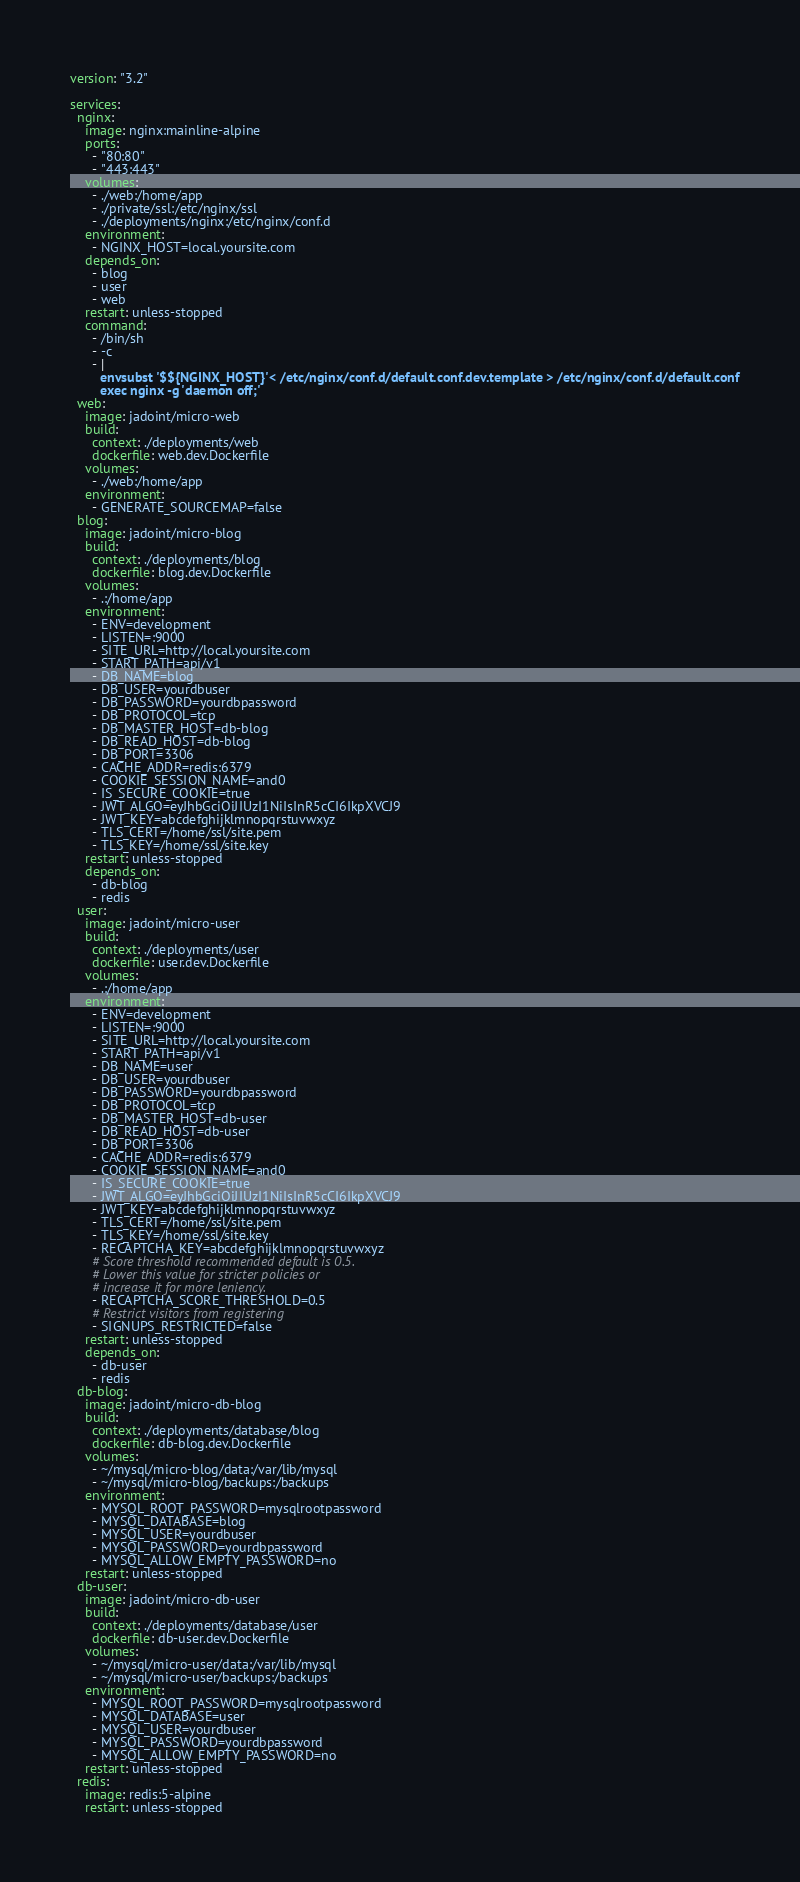Convert code to text. <code><loc_0><loc_0><loc_500><loc_500><_YAML_>version: "3.2"

services:
  nginx:
    image: nginx:mainline-alpine
    ports:
      - "80:80"
      - "443:443"
    volumes:
      - ./web:/home/app
      - ./private/ssl:/etc/nginx/ssl
      - ./deployments/nginx:/etc/nginx/conf.d
    environment:
      - NGINX_HOST=local.yoursite.com
    depends_on:
      - blog
      - user
      - web
    restart: unless-stopped
    command:
      - /bin/sh
      - -c
      - |
        envsubst '$${NGINX_HOST}'< /etc/nginx/conf.d/default.conf.dev.template > /etc/nginx/conf.d/default.conf
        exec nginx -g 'daemon off;'
  web:
    image: jadoint/micro-web
    build:
      context: ./deployments/web
      dockerfile: web.dev.Dockerfile
    volumes:
      - ./web:/home/app
    environment:
      - GENERATE_SOURCEMAP=false
  blog:
    image: jadoint/micro-blog
    build:
      context: ./deployments/blog
      dockerfile: blog.dev.Dockerfile
    volumes:
      - .:/home/app
    environment:
      - ENV=development
      - LISTEN=:9000
      - SITE_URL=http://local.yoursite.com
      - START_PATH=api/v1
      - DB_NAME=blog
      - DB_USER=yourdbuser
      - DB_PASSWORD=yourdbpassword
      - DB_PROTOCOL=tcp
      - DB_MASTER_HOST=db-blog
      - DB_READ_HOST=db-blog
      - DB_PORT=3306
      - CACHE_ADDR=redis:6379
      - COOKIE_SESSION_NAME=and0
      - IS_SECURE_COOKIE=true
      - JWT_ALGO=eyJhbGciOiJIUzI1NiIsInR5cCI6IkpXVCJ9
      - JWT_KEY=abcdefghijklmnopqrstuvwxyz
      - TLS_CERT=/home/ssl/site.pem
      - TLS_KEY=/home/ssl/site.key
    restart: unless-stopped
    depends_on:
      - db-blog
      - redis
  user:
    image: jadoint/micro-user
    build:
      context: ./deployments/user
      dockerfile: user.dev.Dockerfile
    volumes:
      - .:/home/app
    environment:
      - ENV=development
      - LISTEN=:9000
      - SITE_URL=http://local.yoursite.com
      - START_PATH=api/v1
      - DB_NAME=user
      - DB_USER=yourdbuser
      - DB_PASSWORD=yourdbpassword
      - DB_PROTOCOL=tcp
      - DB_MASTER_HOST=db-user
      - DB_READ_HOST=db-user
      - DB_PORT=3306
      - CACHE_ADDR=redis:6379
      - COOKIE_SESSION_NAME=and0
      - IS_SECURE_COOKIE=true
      - JWT_ALGO=eyJhbGciOiJIUzI1NiIsInR5cCI6IkpXVCJ9
      - JWT_KEY=abcdefghijklmnopqrstuvwxyz
      - TLS_CERT=/home/ssl/site.pem
      - TLS_KEY=/home/ssl/site.key
      - RECAPTCHA_KEY=abcdefghijklmnopqrstuvwxyz
      # Score threshold recommended default is 0.5.
      # Lower this value for stricter policies or
      # increase it for more leniency.
      - RECAPTCHA_SCORE_THRESHOLD=0.5
      # Restrict visitors from registering
      - SIGNUPS_RESTRICTED=false
    restart: unless-stopped
    depends_on:
      - db-user
      - redis
  db-blog:
    image: jadoint/micro-db-blog
    build:
      context: ./deployments/database/blog
      dockerfile: db-blog.dev.Dockerfile
    volumes:
      - ~/mysql/micro-blog/data:/var/lib/mysql
      - ~/mysql/micro-blog/backups:/backups
    environment:
      - MYSQL_ROOT_PASSWORD=mysqlrootpassword
      - MYSQL_DATABASE=blog
      - MYSQL_USER=yourdbuser
      - MYSQL_PASSWORD=yourdbpassword
      - MYSQL_ALLOW_EMPTY_PASSWORD=no
    restart: unless-stopped
  db-user:
    image: jadoint/micro-db-user
    build:
      context: ./deployments/database/user
      dockerfile: db-user.dev.Dockerfile
    volumes:
      - ~/mysql/micro-user/data:/var/lib/mysql
      - ~/mysql/micro-user/backups:/backups
    environment:
      - MYSQL_ROOT_PASSWORD=mysqlrootpassword
      - MYSQL_DATABASE=user
      - MYSQL_USER=yourdbuser
      - MYSQL_PASSWORD=yourdbpassword
      - MYSQL_ALLOW_EMPTY_PASSWORD=no
    restart: unless-stopped
  redis:
    image: redis:5-alpine
    restart: unless-stopped
</code> 